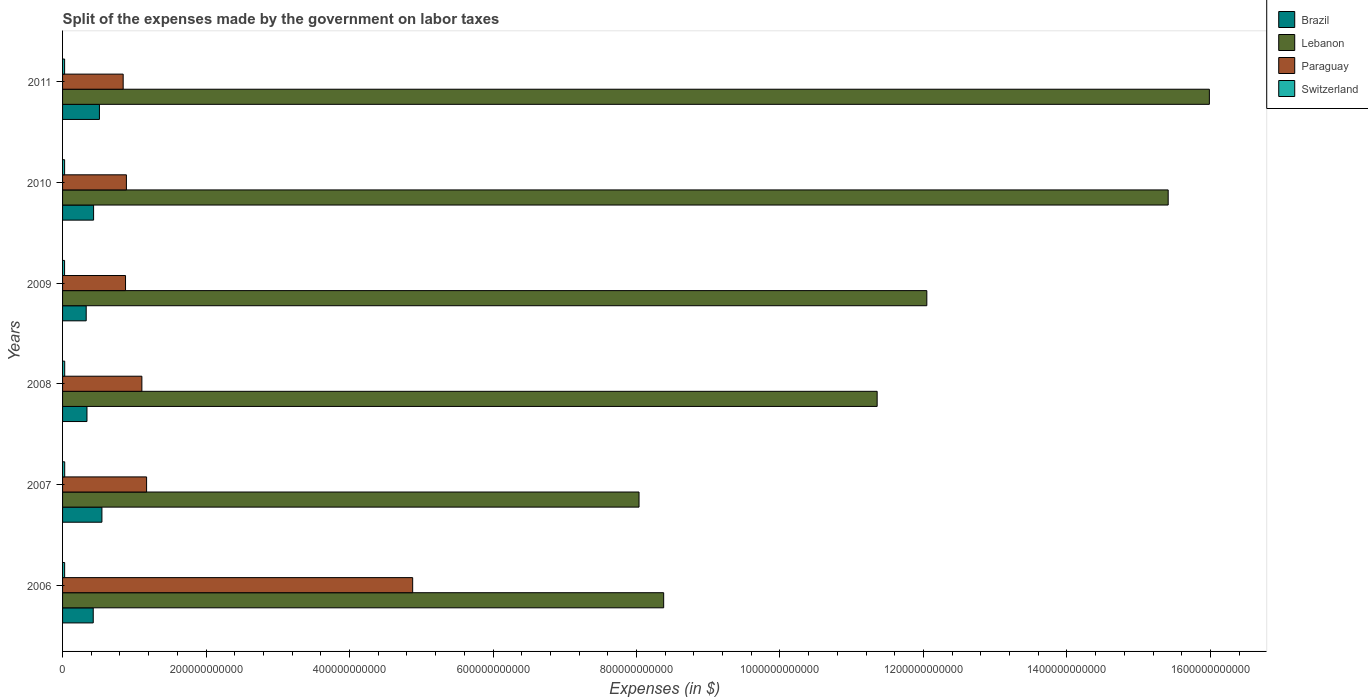How many groups of bars are there?
Provide a succinct answer. 6. What is the label of the 1st group of bars from the top?
Give a very brief answer. 2011. What is the expenses made by the government on labor taxes in Paraguay in 2009?
Offer a terse response. 8.78e+1. Across all years, what is the maximum expenses made by the government on labor taxes in Switzerland?
Ensure brevity in your answer.  2.99e+09. Across all years, what is the minimum expenses made by the government on labor taxes in Brazil?
Provide a short and direct response. 3.30e+1. What is the total expenses made by the government on labor taxes in Lebanon in the graph?
Keep it short and to the point. 7.12e+12. What is the difference between the expenses made by the government on labor taxes in Lebanon in 2007 and that in 2011?
Offer a very short reply. -7.95e+11. What is the difference between the expenses made by the government on labor taxes in Paraguay in 2011 and the expenses made by the government on labor taxes in Lebanon in 2008?
Offer a terse response. -1.05e+12. What is the average expenses made by the government on labor taxes in Brazil per year?
Give a very brief answer. 4.32e+1. In the year 2006, what is the difference between the expenses made by the government on labor taxes in Switzerland and expenses made by the government on labor taxes in Lebanon?
Ensure brevity in your answer.  -8.35e+11. In how many years, is the expenses made by the government on labor taxes in Lebanon greater than 480000000000 $?
Give a very brief answer. 6. What is the ratio of the expenses made by the government on labor taxes in Brazil in 2010 to that in 2011?
Your answer should be compact. 0.84. Is the difference between the expenses made by the government on labor taxes in Switzerland in 2009 and 2011 greater than the difference between the expenses made by the government on labor taxes in Lebanon in 2009 and 2011?
Your answer should be very brief. Yes. What is the difference between the highest and the second highest expenses made by the government on labor taxes in Paraguay?
Keep it short and to the point. 3.71e+11. What is the difference between the highest and the lowest expenses made by the government on labor taxes in Brazil?
Your response must be concise. 2.19e+1. Is the sum of the expenses made by the government on labor taxes in Paraguay in 2007 and 2009 greater than the maximum expenses made by the government on labor taxes in Lebanon across all years?
Offer a very short reply. No. Is it the case that in every year, the sum of the expenses made by the government on labor taxes in Switzerland and expenses made by the government on labor taxes in Brazil is greater than the sum of expenses made by the government on labor taxes in Paraguay and expenses made by the government on labor taxes in Lebanon?
Give a very brief answer. No. What does the 2nd bar from the top in 2008 represents?
Provide a short and direct response. Paraguay. What does the 1st bar from the bottom in 2006 represents?
Ensure brevity in your answer.  Brazil. Is it the case that in every year, the sum of the expenses made by the government on labor taxes in Brazil and expenses made by the government on labor taxes in Switzerland is greater than the expenses made by the government on labor taxes in Lebanon?
Give a very brief answer. No. How many bars are there?
Your response must be concise. 24. What is the difference between two consecutive major ticks on the X-axis?
Your answer should be compact. 2.00e+11. Does the graph contain any zero values?
Your answer should be compact. No. Where does the legend appear in the graph?
Your answer should be compact. Top right. How many legend labels are there?
Make the answer very short. 4. What is the title of the graph?
Provide a short and direct response. Split of the expenses made by the government on labor taxes. What is the label or title of the X-axis?
Offer a terse response. Expenses (in $). What is the Expenses (in $) of Brazil in 2006?
Your answer should be compact. 4.28e+1. What is the Expenses (in $) in Lebanon in 2006?
Offer a terse response. 8.38e+11. What is the Expenses (in $) in Paraguay in 2006?
Your answer should be very brief. 4.88e+11. What is the Expenses (in $) of Switzerland in 2006?
Your answer should be compact. 2.89e+09. What is the Expenses (in $) of Brazil in 2007?
Give a very brief answer. 5.49e+1. What is the Expenses (in $) in Lebanon in 2007?
Provide a succinct answer. 8.04e+11. What is the Expenses (in $) of Paraguay in 2007?
Provide a short and direct response. 1.17e+11. What is the Expenses (in $) in Switzerland in 2007?
Provide a short and direct response. 2.99e+09. What is the Expenses (in $) in Brazil in 2008?
Give a very brief answer. 3.40e+1. What is the Expenses (in $) of Lebanon in 2008?
Offer a terse response. 1.14e+12. What is the Expenses (in $) of Paraguay in 2008?
Ensure brevity in your answer.  1.11e+11. What is the Expenses (in $) of Switzerland in 2008?
Your answer should be compact. 2.97e+09. What is the Expenses (in $) of Brazil in 2009?
Give a very brief answer. 3.30e+1. What is the Expenses (in $) in Lebanon in 2009?
Ensure brevity in your answer.  1.20e+12. What is the Expenses (in $) in Paraguay in 2009?
Provide a succinct answer. 8.78e+1. What is the Expenses (in $) in Switzerland in 2009?
Make the answer very short. 2.81e+09. What is the Expenses (in $) in Brazil in 2010?
Keep it short and to the point. 4.33e+1. What is the Expenses (in $) in Lebanon in 2010?
Your answer should be very brief. 1.54e+12. What is the Expenses (in $) of Paraguay in 2010?
Provide a succinct answer. 8.90e+1. What is the Expenses (in $) of Switzerland in 2010?
Provide a succinct answer. 2.85e+09. What is the Expenses (in $) of Brazil in 2011?
Offer a terse response. 5.14e+1. What is the Expenses (in $) in Lebanon in 2011?
Make the answer very short. 1.60e+12. What is the Expenses (in $) in Paraguay in 2011?
Your response must be concise. 8.45e+1. What is the Expenses (in $) in Switzerland in 2011?
Offer a very short reply. 2.86e+09. Across all years, what is the maximum Expenses (in $) in Brazil?
Provide a short and direct response. 5.49e+1. Across all years, what is the maximum Expenses (in $) in Lebanon?
Make the answer very short. 1.60e+12. Across all years, what is the maximum Expenses (in $) in Paraguay?
Keep it short and to the point. 4.88e+11. Across all years, what is the maximum Expenses (in $) of Switzerland?
Provide a succinct answer. 2.99e+09. Across all years, what is the minimum Expenses (in $) of Brazil?
Ensure brevity in your answer.  3.30e+1. Across all years, what is the minimum Expenses (in $) in Lebanon?
Your answer should be compact. 8.04e+11. Across all years, what is the minimum Expenses (in $) in Paraguay?
Give a very brief answer. 8.45e+1. Across all years, what is the minimum Expenses (in $) of Switzerland?
Provide a succinct answer. 2.81e+09. What is the total Expenses (in $) of Brazil in the graph?
Your answer should be compact. 2.59e+11. What is the total Expenses (in $) of Lebanon in the graph?
Offer a terse response. 7.12e+12. What is the total Expenses (in $) in Paraguay in the graph?
Your answer should be compact. 9.77e+11. What is the total Expenses (in $) of Switzerland in the graph?
Make the answer very short. 1.74e+1. What is the difference between the Expenses (in $) in Brazil in 2006 and that in 2007?
Ensure brevity in your answer.  -1.21e+1. What is the difference between the Expenses (in $) in Lebanon in 2006 and that in 2007?
Provide a succinct answer. 3.43e+1. What is the difference between the Expenses (in $) of Paraguay in 2006 and that in 2007?
Keep it short and to the point. 3.71e+11. What is the difference between the Expenses (in $) in Switzerland in 2006 and that in 2007?
Keep it short and to the point. -1.00e+08. What is the difference between the Expenses (in $) of Brazil in 2006 and that in 2008?
Offer a terse response. 8.73e+09. What is the difference between the Expenses (in $) in Lebanon in 2006 and that in 2008?
Your response must be concise. -2.98e+11. What is the difference between the Expenses (in $) of Paraguay in 2006 and that in 2008?
Keep it short and to the point. 3.77e+11. What is the difference between the Expenses (in $) of Switzerland in 2006 and that in 2008?
Give a very brief answer. -8.54e+07. What is the difference between the Expenses (in $) in Brazil in 2006 and that in 2009?
Offer a terse response. 9.80e+09. What is the difference between the Expenses (in $) in Lebanon in 2006 and that in 2009?
Offer a very short reply. -3.67e+11. What is the difference between the Expenses (in $) in Paraguay in 2006 and that in 2009?
Your answer should be compact. 4.00e+11. What is the difference between the Expenses (in $) of Switzerland in 2006 and that in 2009?
Offer a very short reply. 8.37e+07. What is the difference between the Expenses (in $) of Brazil in 2006 and that in 2010?
Provide a short and direct response. -5.06e+08. What is the difference between the Expenses (in $) of Lebanon in 2006 and that in 2010?
Your answer should be compact. -7.03e+11. What is the difference between the Expenses (in $) in Paraguay in 2006 and that in 2010?
Offer a very short reply. 3.99e+11. What is the difference between the Expenses (in $) in Switzerland in 2006 and that in 2010?
Your response must be concise. 3.46e+07. What is the difference between the Expenses (in $) of Brazil in 2006 and that in 2011?
Offer a very short reply. -8.65e+09. What is the difference between the Expenses (in $) in Lebanon in 2006 and that in 2011?
Provide a short and direct response. -7.61e+11. What is the difference between the Expenses (in $) of Paraguay in 2006 and that in 2011?
Your answer should be compact. 4.04e+11. What is the difference between the Expenses (in $) of Switzerland in 2006 and that in 2011?
Your answer should be very brief. 3.35e+07. What is the difference between the Expenses (in $) in Brazil in 2007 and that in 2008?
Ensure brevity in your answer.  2.08e+1. What is the difference between the Expenses (in $) in Lebanon in 2007 and that in 2008?
Offer a terse response. -3.32e+11. What is the difference between the Expenses (in $) of Paraguay in 2007 and that in 2008?
Ensure brevity in your answer.  6.57e+09. What is the difference between the Expenses (in $) of Switzerland in 2007 and that in 2008?
Ensure brevity in your answer.  1.49e+07. What is the difference between the Expenses (in $) of Brazil in 2007 and that in 2009?
Offer a terse response. 2.19e+1. What is the difference between the Expenses (in $) of Lebanon in 2007 and that in 2009?
Give a very brief answer. -4.01e+11. What is the difference between the Expenses (in $) of Paraguay in 2007 and that in 2009?
Offer a terse response. 2.93e+1. What is the difference between the Expenses (in $) of Switzerland in 2007 and that in 2009?
Your response must be concise. 1.84e+08. What is the difference between the Expenses (in $) in Brazil in 2007 and that in 2010?
Offer a terse response. 1.16e+1. What is the difference between the Expenses (in $) of Lebanon in 2007 and that in 2010?
Offer a very short reply. -7.38e+11. What is the difference between the Expenses (in $) of Paraguay in 2007 and that in 2010?
Provide a succinct answer. 2.81e+1. What is the difference between the Expenses (in $) of Switzerland in 2007 and that in 2010?
Make the answer very short. 1.35e+08. What is the difference between the Expenses (in $) in Brazil in 2007 and that in 2011?
Your answer should be compact. 3.46e+09. What is the difference between the Expenses (in $) of Lebanon in 2007 and that in 2011?
Provide a short and direct response. -7.95e+11. What is the difference between the Expenses (in $) in Paraguay in 2007 and that in 2011?
Offer a very short reply. 3.26e+1. What is the difference between the Expenses (in $) of Switzerland in 2007 and that in 2011?
Provide a succinct answer. 1.34e+08. What is the difference between the Expenses (in $) of Brazil in 2008 and that in 2009?
Ensure brevity in your answer.  1.07e+09. What is the difference between the Expenses (in $) in Lebanon in 2008 and that in 2009?
Make the answer very short. -6.92e+1. What is the difference between the Expenses (in $) of Paraguay in 2008 and that in 2009?
Offer a very short reply. 2.28e+1. What is the difference between the Expenses (in $) of Switzerland in 2008 and that in 2009?
Your answer should be compact. 1.69e+08. What is the difference between the Expenses (in $) in Brazil in 2008 and that in 2010?
Give a very brief answer. -9.23e+09. What is the difference between the Expenses (in $) in Lebanon in 2008 and that in 2010?
Offer a very short reply. -4.06e+11. What is the difference between the Expenses (in $) of Paraguay in 2008 and that in 2010?
Your answer should be compact. 2.16e+1. What is the difference between the Expenses (in $) in Switzerland in 2008 and that in 2010?
Ensure brevity in your answer.  1.20e+08. What is the difference between the Expenses (in $) in Brazil in 2008 and that in 2011?
Ensure brevity in your answer.  -1.74e+1. What is the difference between the Expenses (in $) of Lebanon in 2008 and that in 2011?
Make the answer very short. -4.63e+11. What is the difference between the Expenses (in $) of Paraguay in 2008 and that in 2011?
Offer a terse response. 2.61e+1. What is the difference between the Expenses (in $) of Switzerland in 2008 and that in 2011?
Provide a short and direct response. 1.19e+08. What is the difference between the Expenses (in $) in Brazil in 2009 and that in 2010?
Make the answer very short. -1.03e+1. What is the difference between the Expenses (in $) of Lebanon in 2009 and that in 2010?
Your answer should be very brief. -3.36e+11. What is the difference between the Expenses (in $) of Paraguay in 2009 and that in 2010?
Make the answer very short. -1.20e+09. What is the difference between the Expenses (in $) of Switzerland in 2009 and that in 2010?
Your answer should be compact. -4.91e+07. What is the difference between the Expenses (in $) in Brazil in 2009 and that in 2011?
Offer a very short reply. -1.84e+1. What is the difference between the Expenses (in $) of Lebanon in 2009 and that in 2011?
Offer a terse response. -3.94e+11. What is the difference between the Expenses (in $) in Paraguay in 2009 and that in 2011?
Provide a short and direct response. 3.30e+09. What is the difference between the Expenses (in $) in Switzerland in 2009 and that in 2011?
Offer a terse response. -5.02e+07. What is the difference between the Expenses (in $) in Brazil in 2010 and that in 2011?
Keep it short and to the point. -8.14e+09. What is the difference between the Expenses (in $) of Lebanon in 2010 and that in 2011?
Offer a very short reply. -5.74e+1. What is the difference between the Expenses (in $) of Paraguay in 2010 and that in 2011?
Ensure brevity in your answer.  4.50e+09. What is the difference between the Expenses (in $) of Switzerland in 2010 and that in 2011?
Your response must be concise. -1.09e+06. What is the difference between the Expenses (in $) of Brazil in 2006 and the Expenses (in $) of Lebanon in 2007?
Your answer should be compact. -7.61e+11. What is the difference between the Expenses (in $) in Brazil in 2006 and the Expenses (in $) in Paraguay in 2007?
Provide a succinct answer. -7.44e+1. What is the difference between the Expenses (in $) of Brazil in 2006 and the Expenses (in $) of Switzerland in 2007?
Offer a very short reply. 3.98e+1. What is the difference between the Expenses (in $) of Lebanon in 2006 and the Expenses (in $) of Paraguay in 2007?
Offer a very short reply. 7.21e+11. What is the difference between the Expenses (in $) of Lebanon in 2006 and the Expenses (in $) of Switzerland in 2007?
Make the answer very short. 8.35e+11. What is the difference between the Expenses (in $) in Paraguay in 2006 and the Expenses (in $) in Switzerland in 2007?
Your answer should be compact. 4.85e+11. What is the difference between the Expenses (in $) in Brazil in 2006 and the Expenses (in $) in Lebanon in 2008?
Give a very brief answer. -1.09e+12. What is the difference between the Expenses (in $) of Brazil in 2006 and the Expenses (in $) of Paraguay in 2008?
Offer a very short reply. -6.78e+1. What is the difference between the Expenses (in $) of Brazil in 2006 and the Expenses (in $) of Switzerland in 2008?
Your response must be concise. 3.98e+1. What is the difference between the Expenses (in $) in Lebanon in 2006 and the Expenses (in $) in Paraguay in 2008?
Your response must be concise. 7.27e+11. What is the difference between the Expenses (in $) in Lebanon in 2006 and the Expenses (in $) in Switzerland in 2008?
Keep it short and to the point. 8.35e+11. What is the difference between the Expenses (in $) in Paraguay in 2006 and the Expenses (in $) in Switzerland in 2008?
Your response must be concise. 4.85e+11. What is the difference between the Expenses (in $) of Brazil in 2006 and the Expenses (in $) of Lebanon in 2009?
Your answer should be very brief. -1.16e+12. What is the difference between the Expenses (in $) of Brazil in 2006 and the Expenses (in $) of Paraguay in 2009?
Your answer should be very brief. -4.50e+1. What is the difference between the Expenses (in $) of Brazil in 2006 and the Expenses (in $) of Switzerland in 2009?
Offer a terse response. 3.99e+1. What is the difference between the Expenses (in $) in Lebanon in 2006 and the Expenses (in $) in Paraguay in 2009?
Offer a very short reply. 7.50e+11. What is the difference between the Expenses (in $) in Lebanon in 2006 and the Expenses (in $) in Switzerland in 2009?
Offer a terse response. 8.35e+11. What is the difference between the Expenses (in $) of Paraguay in 2006 and the Expenses (in $) of Switzerland in 2009?
Your answer should be compact. 4.85e+11. What is the difference between the Expenses (in $) in Brazil in 2006 and the Expenses (in $) in Lebanon in 2010?
Provide a short and direct response. -1.50e+12. What is the difference between the Expenses (in $) in Brazil in 2006 and the Expenses (in $) in Paraguay in 2010?
Keep it short and to the point. -4.62e+1. What is the difference between the Expenses (in $) of Brazil in 2006 and the Expenses (in $) of Switzerland in 2010?
Make the answer very short. 3.99e+1. What is the difference between the Expenses (in $) in Lebanon in 2006 and the Expenses (in $) in Paraguay in 2010?
Offer a terse response. 7.49e+11. What is the difference between the Expenses (in $) of Lebanon in 2006 and the Expenses (in $) of Switzerland in 2010?
Make the answer very short. 8.35e+11. What is the difference between the Expenses (in $) in Paraguay in 2006 and the Expenses (in $) in Switzerland in 2010?
Make the answer very short. 4.85e+11. What is the difference between the Expenses (in $) of Brazil in 2006 and the Expenses (in $) of Lebanon in 2011?
Your answer should be compact. -1.56e+12. What is the difference between the Expenses (in $) of Brazil in 2006 and the Expenses (in $) of Paraguay in 2011?
Your answer should be very brief. -4.17e+1. What is the difference between the Expenses (in $) of Brazil in 2006 and the Expenses (in $) of Switzerland in 2011?
Provide a succinct answer. 3.99e+1. What is the difference between the Expenses (in $) of Lebanon in 2006 and the Expenses (in $) of Paraguay in 2011?
Make the answer very short. 7.53e+11. What is the difference between the Expenses (in $) in Lebanon in 2006 and the Expenses (in $) in Switzerland in 2011?
Keep it short and to the point. 8.35e+11. What is the difference between the Expenses (in $) in Paraguay in 2006 and the Expenses (in $) in Switzerland in 2011?
Provide a short and direct response. 4.85e+11. What is the difference between the Expenses (in $) in Brazil in 2007 and the Expenses (in $) in Lebanon in 2008?
Your answer should be very brief. -1.08e+12. What is the difference between the Expenses (in $) in Brazil in 2007 and the Expenses (in $) in Paraguay in 2008?
Offer a very short reply. -5.57e+1. What is the difference between the Expenses (in $) of Brazil in 2007 and the Expenses (in $) of Switzerland in 2008?
Your answer should be very brief. 5.19e+1. What is the difference between the Expenses (in $) in Lebanon in 2007 and the Expenses (in $) in Paraguay in 2008?
Give a very brief answer. 6.93e+11. What is the difference between the Expenses (in $) of Lebanon in 2007 and the Expenses (in $) of Switzerland in 2008?
Keep it short and to the point. 8.01e+11. What is the difference between the Expenses (in $) in Paraguay in 2007 and the Expenses (in $) in Switzerland in 2008?
Offer a very short reply. 1.14e+11. What is the difference between the Expenses (in $) in Brazil in 2007 and the Expenses (in $) in Lebanon in 2009?
Your answer should be very brief. -1.15e+12. What is the difference between the Expenses (in $) of Brazil in 2007 and the Expenses (in $) of Paraguay in 2009?
Your answer should be very brief. -3.29e+1. What is the difference between the Expenses (in $) of Brazil in 2007 and the Expenses (in $) of Switzerland in 2009?
Keep it short and to the point. 5.21e+1. What is the difference between the Expenses (in $) in Lebanon in 2007 and the Expenses (in $) in Paraguay in 2009?
Give a very brief answer. 7.16e+11. What is the difference between the Expenses (in $) in Lebanon in 2007 and the Expenses (in $) in Switzerland in 2009?
Provide a succinct answer. 8.01e+11. What is the difference between the Expenses (in $) of Paraguay in 2007 and the Expenses (in $) of Switzerland in 2009?
Make the answer very short. 1.14e+11. What is the difference between the Expenses (in $) of Brazil in 2007 and the Expenses (in $) of Lebanon in 2010?
Your answer should be compact. -1.49e+12. What is the difference between the Expenses (in $) of Brazil in 2007 and the Expenses (in $) of Paraguay in 2010?
Your response must be concise. -3.41e+1. What is the difference between the Expenses (in $) of Brazil in 2007 and the Expenses (in $) of Switzerland in 2010?
Make the answer very short. 5.20e+1. What is the difference between the Expenses (in $) of Lebanon in 2007 and the Expenses (in $) of Paraguay in 2010?
Give a very brief answer. 7.15e+11. What is the difference between the Expenses (in $) of Lebanon in 2007 and the Expenses (in $) of Switzerland in 2010?
Your answer should be compact. 8.01e+11. What is the difference between the Expenses (in $) of Paraguay in 2007 and the Expenses (in $) of Switzerland in 2010?
Your response must be concise. 1.14e+11. What is the difference between the Expenses (in $) in Brazil in 2007 and the Expenses (in $) in Lebanon in 2011?
Make the answer very short. -1.54e+12. What is the difference between the Expenses (in $) in Brazil in 2007 and the Expenses (in $) in Paraguay in 2011?
Your answer should be very brief. -2.96e+1. What is the difference between the Expenses (in $) of Brazil in 2007 and the Expenses (in $) of Switzerland in 2011?
Your answer should be compact. 5.20e+1. What is the difference between the Expenses (in $) of Lebanon in 2007 and the Expenses (in $) of Paraguay in 2011?
Keep it short and to the point. 7.19e+11. What is the difference between the Expenses (in $) in Lebanon in 2007 and the Expenses (in $) in Switzerland in 2011?
Offer a very short reply. 8.01e+11. What is the difference between the Expenses (in $) in Paraguay in 2007 and the Expenses (in $) in Switzerland in 2011?
Your response must be concise. 1.14e+11. What is the difference between the Expenses (in $) in Brazil in 2008 and the Expenses (in $) in Lebanon in 2009?
Make the answer very short. -1.17e+12. What is the difference between the Expenses (in $) of Brazil in 2008 and the Expenses (in $) of Paraguay in 2009?
Keep it short and to the point. -5.38e+1. What is the difference between the Expenses (in $) in Brazil in 2008 and the Expenses (in $) in Switzerland in 2009?
Make the answer very short. 3.12e+1. What is the difference between the Expenses (in $) of Lebanon in 2008 and the Expenses (in $) of Paraguay in 2009?
Make the answer very short. 1.05e+12. What is the difference between the Expenses (in $) in Lebanon in 2008 and the Expenses (in $) in Switzerland in 2009?
Provide a succinct answer. 1.13e+12. What is the difference between the Expenses (in $) of Paraguay in 2008 and the Expenses (in $) of Switzerland in 2009?
Provide a succinct answer. 1.08e+11. What is the difference between the Expenses (in $) of Brazil in 2008 and the Expenses (in $) of Lebanon in 2010?
Your answer should be very brief. -1.51e+12. What is the difference between the Expenses (in $) in Brazil in 2008 and the Expenses (in $) in Paraguay in 2010?
Your response must be concise. -5.50e+1. What is the difference between the Expenses (in $) in Brazil in 2008 and the Expenses (in $) in Switzerland in 2010?
Your response must be concise. 3.12e+1. What is the difference between the Expenses (in $) in Lebanon in 2008 and the Expenses (in $) in Paraguay in 2010?
Offer a terse response. 1.05e+12. What is the difference between the Expenses (in $) in Lebanon in 2008 and the Expenses (in $) in Switzerland in 2010?
Provide a short and direct response. 1.13e+12. What is the difference between the Expenses (in $) of Paraguay in 2008 and the Expenses (in $) of Switzerland in 2010?
Your answer should be very brief. 1.08e+11. What is the difference between the Expenses (in $) in Brazil in 2008 and the Expenses (in $) in Lebanon in 2011?
Provide a short and direct response. -1.56e+12. What is the difference between the Expenses (in $) in Brazil in 2008 and the Expenses (in $) in Paraguay in 2011?
Give a very brief answer. -5.05e+1. What is the difference between the Expenses (in $) in Brazil in 2008 and the Expenses (in $) in Switzerland in 2011?
Keep it short and to the point. 3.12e+1. What is the difference between the Expenses (in $) in Lebanon in 2008 and the Expenses (in $) in Paraguay in 2011?
Your answer should be very brief. 1.05e+12. What is the difference between the Expenses (in $) in Lebanon in 2008 and the Expenses (in $) in Switzerland in 2011?
Ensure brevity in your answer.  1.13e+12. What is the difference between the Expenses (in $) of Paraguay in 2008 and the Expenses (in $) of Switzerland in 2011?
Give a very brief answer. 1.08e+11. What is the difference between the Expenses (in $) in Brazil in 2009 and the Expenses (in $) in Lebanon in 2010?
Your answer should be very brief. -1.51e+12. What is the difference between the Expenses (in $) in Brazil in 2009 and the Expenses (in $) in Paraguay in 2010?
Make the answer very short. -5.60e+1. What is the difference between the Expenses (in $) in Brazil in 2009 and the Expenses (in $) in Switzerland in 2010?
Make the answer very short. 3.01e+1. What is the difference between the Expenses (in $) in Lebanon in 2009 and the Expenses (in $) in Paraguay in 2010?
Offer a very short reply. 1.12e+12. What is the difference between the Expenses (in $) of Lebanon in 2009 and the Expenses (in $) of Switzerland in 2010?
Make the answer very short. 1.20e+12. What is the difference between the Expenses (in $) in Paraguay in 2009 and the Expenses (in $) in Switzerland in 2010?
Keep it short and to the point. 8.49e+1. What is the difference between the Expenses (in $) in Brazil in 2009 and the Expenses (in $) in Lebanon in 2011?
Offer a terse response. -1.57e+12. What is the difference between the Expenses (in $) in Brazil in 2009 and the Expenses (in $) in Paraguay in 2011?
Your response must be concise. -5.15e+1. What is the difference between the Expenses (in $) of Brazil in 2009 and the Expenses (in $) of Switzerland in 2011?
Provide a short and direct response. 3.01e+1. What is the difference between the Expenses (in $) in Lebanon in 2009 and the Expenses (in $) in Paraguay in 2011?
Make the answer very short. 1.12e+12. What is the difference between the Expenses (in $) of Lebanon in 2009 and the Expenses (in $) of Switzerland in 2011?
Ensure brevity in your answer.  1.20e+12. What is the difference between the Expenses (in $) of Paraguay in 2009 and the Expenses (in $) of Switzerland in 2011?
Your answer should be compact. 8.49e+1. What is the difference between the Expenses (in $) in Brazil in 2010 and the Expenses (in $) in Lebanon in 2011?
Your answer should be very brief. -1.56e+12. What is the difference between the Expenses (in $) of Brazil in 2010 and the Expenses (in $) of Paraguay in 2011?
Provide a short and direct response. -4.12e+1. What is the difference between the Expenses (in $) of Brazil in 2010 and the Expenses (in $) of Switzerland in 2011?
Keep it short and to the point. 4.04e+1. What is the difference between the Expenses (in $) of Lebanon in 2010 and the Expenses (in $) of Paraguay in 2011?
Offer a terse response. 1.46e+12. What is the difference between the Expenses (in $) in Lebanon in 2010 and the Expenses (in $) in Switzerland in 2011?
Give a very brief answer. 1.54e+12. What is the difference between the Expenses (in $) in Paraguay in 2010 and the Expenses (in $) in Switzerland in 2011?
Your answer should be very brief. 8.61e+1. What is the average Expenses (in $) in Brazil per year?
Ensure brevity in your answer.  4.32e+1. What is the average Expenses (in $) of Lebanon per year?
Offer a very short reply. 1.19e+12. What is the average Expenses (in $) in Paraguay per year?
Your answer should be very brief. 1.63e+11. What is the average Expenses (in $) of Switzerland per year?
Give a very brief answer. 2.89e+09. In the year 2006, what is the difference between the Expenses (in $) of Brazil and Expenses (in $) of Lebanon?
Provide a succinct answer. -7.95e+11. In the year 2006, what is the difference between the Expenses (in $) of Brazil and Expenses (in $) of Paraguay?
Ensure brevity in your answer.  -4.45e+11. In the year 2006, what is the difference between the Expenses (in $) in Brazil and Expenses (in $) in Switzerland?
Keep it short and to the point. 3.99e+1. In the year 2006, what is the difference between the Expenses (in $) of Lebanon and Expenses (in $) of Paraguay?
Provide a short and direct response. 3.50e+11. In the year 2006, what is the difference between the Expenses (in $) of Lebanon and Expenses (in $) of Switzerland?
Offer a terse response. 8.35e+11. In the year 2006, what is the difference between the Expenses (in $) of Paraguay and Expenses (in $) of Switzerland?
Provide a short and direct response. 4.85e+11. In the year 2007, what is the difference between the Expenses (in $) of Brazil and Expenses (in $) of Lebanon?
Give a very brief answer. -7.49e+11. In the year 2007, what is the difference between the Expenses (in $) of Brazil and Expenses (in $) of Paraguay?
Keep it short and to the point. -6.23e+1. In the year 2007, what is the difference between the Expenses (in $) of Brazil and Expenses (in $) of Switzerland?
Provide a succinct answer. 5.19e+1. In the year 2007, what is the difference between the Expenses (in $) of Lebanon and Expenses (in $) of Paraguay?
Offer a very short reply. 6.86e+11. In the year 2007, what is the difference between the Expenses (in $) of Lebanon and Expenses (in $) of Switzerland?
Provide a succinct answer. 8.01e+11. In the year 2007, what is the difference between the Expenses (in $) of Paraguay and Expenses (in $) of Switzerland?
Provide a succinct answer. 1.14e+11. In the year 2008, what is the difference between the Expenses (in $) in Brazil and Expenses (in $) in Lebanon?
Ensure brevity in your answer.  -1.10e+12. In the year 2008, what is the difference between the Expenses (in $) in Brazil and Expenses (in $) in Paraguay?
Give a very brief answer. -7.65e+1. In the year 2008, what is the difference between the Expenses (in $) in Brazil and Expenses (in $) in Switzerland?
Give a very brief answer. 3.10e+1. In the year 2008, what is the difference between the Expenses (in $) of Lebanon and Expenses (in $) of Paraguay?
Ensure brevity in your answer.  1.02e+12. In the year 2008, what is the difference between the Expenses (in $) in Lebanon and Expenses (in $) in Switzerland?
Give a very brief answer. 1.13e+12. In the year 2008, what is the difference between the Expenses (in $) of Paraguay and Expenses (in $) of Switzerland?
Ensure brevity in your answer.  1.08e+11. In the year 2009, what is the difference between the Expenses (in $) of Brazil and Expenses (in $) of Lebanon?
Offer a terse response. -1.17e+12. In the year 2009, what is the difference between the Expenses (in $) of Brazil and Expenses (in $) of Paraguay?
Offer a terse response. -5.48e+1. In the year 2009, what is the difference between the Expenses (in $) in Brazil and Expenses (in $) in Switzerland?
Make the answer very short. 3.01e+1. In the year 2009, what is the difference between the Expenses (in $) of Lebanon and Expenses (in $) of Paraguay?
Provide a short and direct response. 1.12e+12. In the year 2009, what is the difference between the Expenses (in $) of Lebanon and Expenses (in $) of Switzerland?
Offer a very short reply. 1.20e+12. In the year 2009, what is the difference between the Expenses (in $) of Paraguay and Expenses (in $) of Switzerland?
Make the answer very short. 8.50e+1. In the year 2010, what is the difference between the Expenses (in $) in Brazil and Expenses (in $) in Lebanon?
Your response must be concise. -1.50e+12. In the year 2010, what is the difference between the Expenses (in $) in Brazil and Expenses (in $) in Paraguay?
Make the answer very short. -4.57e+1. In the year 2010, what is the difference between the Expenses (in $) in Brazil and Expenses (in $) in Switzerland?
Provide a succinct answer. 4.04e+1. In the year 2010, what is the difference between the Expenses (in $) in Lebanon and Expenses (in $) in Paraguay?
Offer a terse response. 1.45e+12. In the year 2010, what is the difference between the Expenses (in $) in Lebanon and Expenses (in $) in Switzerland?
Provide a succinct answer. 1.54e+12. In the year 2010, what is the difference between the Expenses (in $) of Paraguay and Expenses (in $) of Switzerland?
Offer a very short reply. 8.61e+1. In the year 2011, what is the difference between the Expenses (in $) of Brazil and Expenses (in $) of Lebanon?
Your answer should be very brief. -1.55e+12. In the year 2011, what is the difference between the Expenses (in $) of Brazil and Expenses (in $) of Paraguay?
Your response must be concise. -3.31e+1. In the year 2011, what is the difference between the Expenses (in $) of Brazil and Expenses (in $) of Switzerland?
Offer a very short reply. 4.85e+1. In the year 2011, what is the difference between the Expenses (in $) in Lebanon and Expenses (in $) in Paraguay?
Provide a succinct answer. 1.51e+12. In the year 2011, what is the difference between the Expenses (in $) in Lebanon and Expenses (in $) in Switzerland?
Offer a very short reply. 1.60e+12. In the year 2011, what is the difference between the Expenses (in $) of Paraguay and Expenses (in $) of Switzerland?
Make the answer very short. 8.16e+1. What is the ratio of the Expenses (in $) in Brazil in 2006 to that in 2007?
Make the answer very short. 0.78. What is the ratio of the Expenses (in $) of Lebanon in 2006 to that in 2007?
Make the answer very short. 1.04. What is the ratio of the Expenses (in $) of Paraguay in 2006 to that in 2007?
Make the answer very short. 4.17. What is the ratio of the Expenses (in $) of Switzerland in 2006 to that in 2007?
Provide a short and direct response. 0.97. What is the ratio of the Expenses (in $) of Brazil in 2006 to that in 2008?
Your answer should be compact. 1.26. What is the ratio of the Expenses (in $) in Lebanon in 2006 to that in 2008?
Ensure brevity in your answer.  0.74. What is the ratio of the Expenses (in $) in Paraguay in 2006 to that in 2008?
Provide a short and direct response. 4.41. What is the ratio of the Expenses (in $) in Switzerland in 2006 to that in 2008?
Your answer should be very brief. 0.97. What is the ratio of the Expenses (in $) of Brazil in 2006 to that in 2009?
Make the answer very short. 1.3. What is the ratio of the Expenses (in $) of Lebanon in 2006 to that in 2009?
Provide a succinct answer. 0.7. What is the ratio of the Expenses (in $) in Paraguay in 2006 to that in 2009?
Provide a succinct answer. 5.56. What is the ratio of the Expenses (in $) of Switzerland in 2006 to that in 2009?
Offer a terse response. 1.03. What is the ratio of the Expenses (in $) in Brazil in 2006 to that in 2010?
Provide a short and direct response. 0.99. What is the ratio of the Expenses (in $) in Lebanon in 2006 to that in 2010?
Offer a very short reply. 0.54. What is the ratio of the Expenses (in $) of Paraguay in 2006 to that in 2010?
Offer a terse response. 5.48. What is the ratio of the Expenses (in $) of Switzerland in 2006 to that in 2010?
Your response must be concise. 1.01. What is the ratio of the Expenses (in $) in Brazil in 2006 to that in 2011?
Make the answer very short. 0.83. What is the ratio of the Expenses (in $) in Lebanon in 2006 to that in 2011?
Your answer should be compact. 0.52. What is the ratio of the Expenses (in $) in Paraguay in 2006 to that in 2011?
Make the answer very short. 5.78. What is the ratio of the Expenses (in $) of Switzerland in 2006 to that in 2011?
Make the answer very short. 1.01. What is the ratio of the Expenses (in $) in Brazil in 2007 to that in 2008?
Give a very brief answer. 1.61. What is the ratio of the Expenses (in $) in Lebanon in 2007 to that in 2008?
Your answer should be compact. 0.71. What is the ratio of the Expenses (in $) of Paraguay in 2007 to that in 2008?
Your answer should be very brief. 1.06. What is the ratio of the Expenses (in $) of Brazil in 2007 to that in 2009?
Your response must be concise. 1.66. What is the ratio of the Expenses (in $) in Lebanon in 2007 to that in 2009?
Give a very brief answer. 0.67. What is the ratio of the Expenses (in $) in Paraguay in 2007 to that in 2009?
Ensure brevity in your answer.  1.33. What is the ratio of the Expenses (in $) in Switzerland in 2007 to that in 2009?
Keep it short and to the point. 1.07. What is the ratio of the Expenses (in $) in Brazil in 2007 to that in 2010?
Provide a short and direct response. 1.27. What is the ratio of the Expenses (in $) of Lebanon in 2007 to that in 2010?
Provide a succinct answer. 0.52. What is the ratio of the Expenses (in $) of Paraguay in 2007 to that in 2010?
Keep it short and to the point. 1.32. What is the ratio of the Expenses (in $) of Switzerland in 2007 to that in 2010?
Provide a succinct answer. 1.05. What is the ratio of the Expenses (in $) of Brazil in 2007 to that in 2011?
Give a very brief answer. 1.07. What is the ratio of the Expenses (in $) in Lebanon in 2007 to that in 2011?
Give a very brief answer. 0.5. What is the ratio of the Expenses (in $) in Paraguay in 2007 to that in 2011?
Ensure brevity in your answer.  1.39. What is the ratio of the Expenses (in $) in Switzerland in 2007 to that in 2011?
Provide a succinct answer. 1.05. What is the ratio of the Expenses (in $) in Brazil in 2008 to that in 2009?
Give a very brief answer. 1.03. What is the ratio of the Expenses (in $) of Lebanon in 2008 to that in 2009?
Your response must be concise. 0.94. What is the ratio of the Expenses (in $) in Paraguay in 2008 to that in 2009?
Provide a short and direct response. 1.26. What is the ratio of the Expenses (in $) in Switzerland in 2008 to that in 2009?
Your response must be concise. 1.06. What is the ratio of the Expenses (in $) in Brazil in 2008 to that in 2010?
Provide a short and direct response. 0.79. What is the ratio of the Expenses (in $) of Lebanon in 2008 to that in 2010?
Give a very brief answer. 0.74. What is the ratio of the Expenses (in $) of Paraguay in 2008 to that in 2010?
Give a very brief answer. 1.24. What is the ratio of the Expenses (in $) in Switzerland in 2008 to that in 2010?
Your response must be concise. 1.04. What is the ratio of the Expenses (in $) in Brazil in 2008 to that in 2011?
Give a very brief answer. 0.66. What is the ratio of the Expenses (in $) of Lebanon in 2008 to that in 2011?
Give a very brief answer. 0.71. What is the ratio of the Expenses (in $) in Paraguay in 2008 to that in 2011?
Keep it short and to the point. 1.31. What is the ratio of the Expenses (in $) in Switzerland in 2008 to that in 2011?
Make the answer very short. 1.04. What is the ratio of the Expenses (in $) in Brazil in 2009 to that in 2010?
Your answer should be very brief. 0.76. What is the ratio of the Expenses (in $) in Lebanon in 2009 to that in 2010?
Provide a short and direct response. 0.78. What is the ratio of the Expenses (in $) of Paraguay in 2009 to that in 2010?
Offer a very short reply. 0.99. What is the ratio of the Expenses (in $) of Switzerland in 2009 to that in 2010?
Provide a succinct answer. 0.98. What is the ratio of the Expenses (in $) of Brazil in 2009 to that in 2011?
Keep it short and to the point. 0.64. What is the ratio of the Expenses (in $) of Lebanon in 2009 to that in 2011?
Your answer should be compact. 0.75. What is the ratio of the Expenses (in $) of Paraguay in 2009 to that in 2011?
Give a very brief answer. 1.04. What is the ratio of the Expenses (in $) in Switzerland in 2009 to that in 2011?
Provide a succinct answer. 0.98. What is the ratio of the Expenses (in $) in Brazil in 2010 to that in 2011?
Your response must be concise. 0.84. What is the ratio of the Expenses (in $) in Lebanon in 2010 to that in 2011?
Offer a very short reply. 0.96. What is the ratio of the Expenses (in $) of Paraguay in 2010 to that in 2011?
Make the answer very short. 1.05. What is the difference between the highest and the second highest Expenses (in $) of Brazil?
Provide a succinct answer. 3.46e+09. What is the difference between the highest and the second highest Expenses (in $) in Lebanon?
Your response must be concise. 5.74e+1. What is the difference between the highest and the second highest Expenses (in $) of Paraguay?
Ensure brevity in your answer.  3.71e+11. What is the difference between the highest and the second highest Expenses (in $) in Switzerland?
Offer a terse response. 1.49e+07. What is the difference between the highest and the lowest Expenses (in $) of Brazil?
Provide a short and direct response. 2.19e+1. What is the difference between the highest and the lowest Expenses (in $) of Lebanon?
Offer a very short reply. 7.95e+11. What is the difference between the highest and the lowest Expenses (in $) of Paraguay?
Make the answer very short. 4.04e+11. What is the difference between the highest and the lowest Expenses (in $) of Switzerland?
Keep it short and to the point. 1.84e+08. 